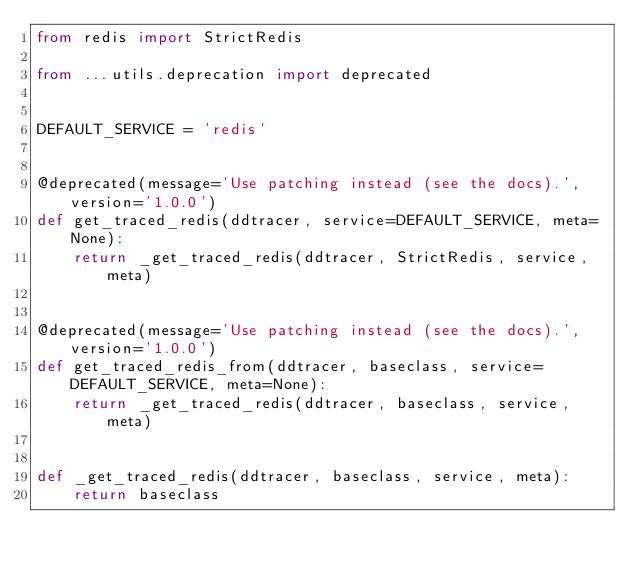Convert code to text. <code><loc_0><loc_0><loc_500><loc_500><_Python_>from redis import StrictRedis

from ...utils.deprecation import deprecated


DEFAULT_SERVICE = 'redis'


@deprecated(message='Use patching instead (see the docs).', version='1.0.0')
def get_traced_redis(ddtracer, service=DEFAULT_SERVICE, meta=None):
    return _get_traced_redis(ddtracer, StrictRedis, service, meta)


@deprecated(message='Use patching instead (see the docs).', version='1.0.0')
def get_traced_redis_from(ddtracer, baseclass, service=DEFAULT_SERVICE, meta=None):
    return _get_traced_redis(ddtracer, baseclass, service, meta)


def _get_traced_redis(ddtracer, baseclass, service, meta):
    return baseclass
</code> 